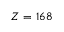<formula> <loc_0><loc_0><loc_500><loc_500>Z = 1 6 8</formula> 